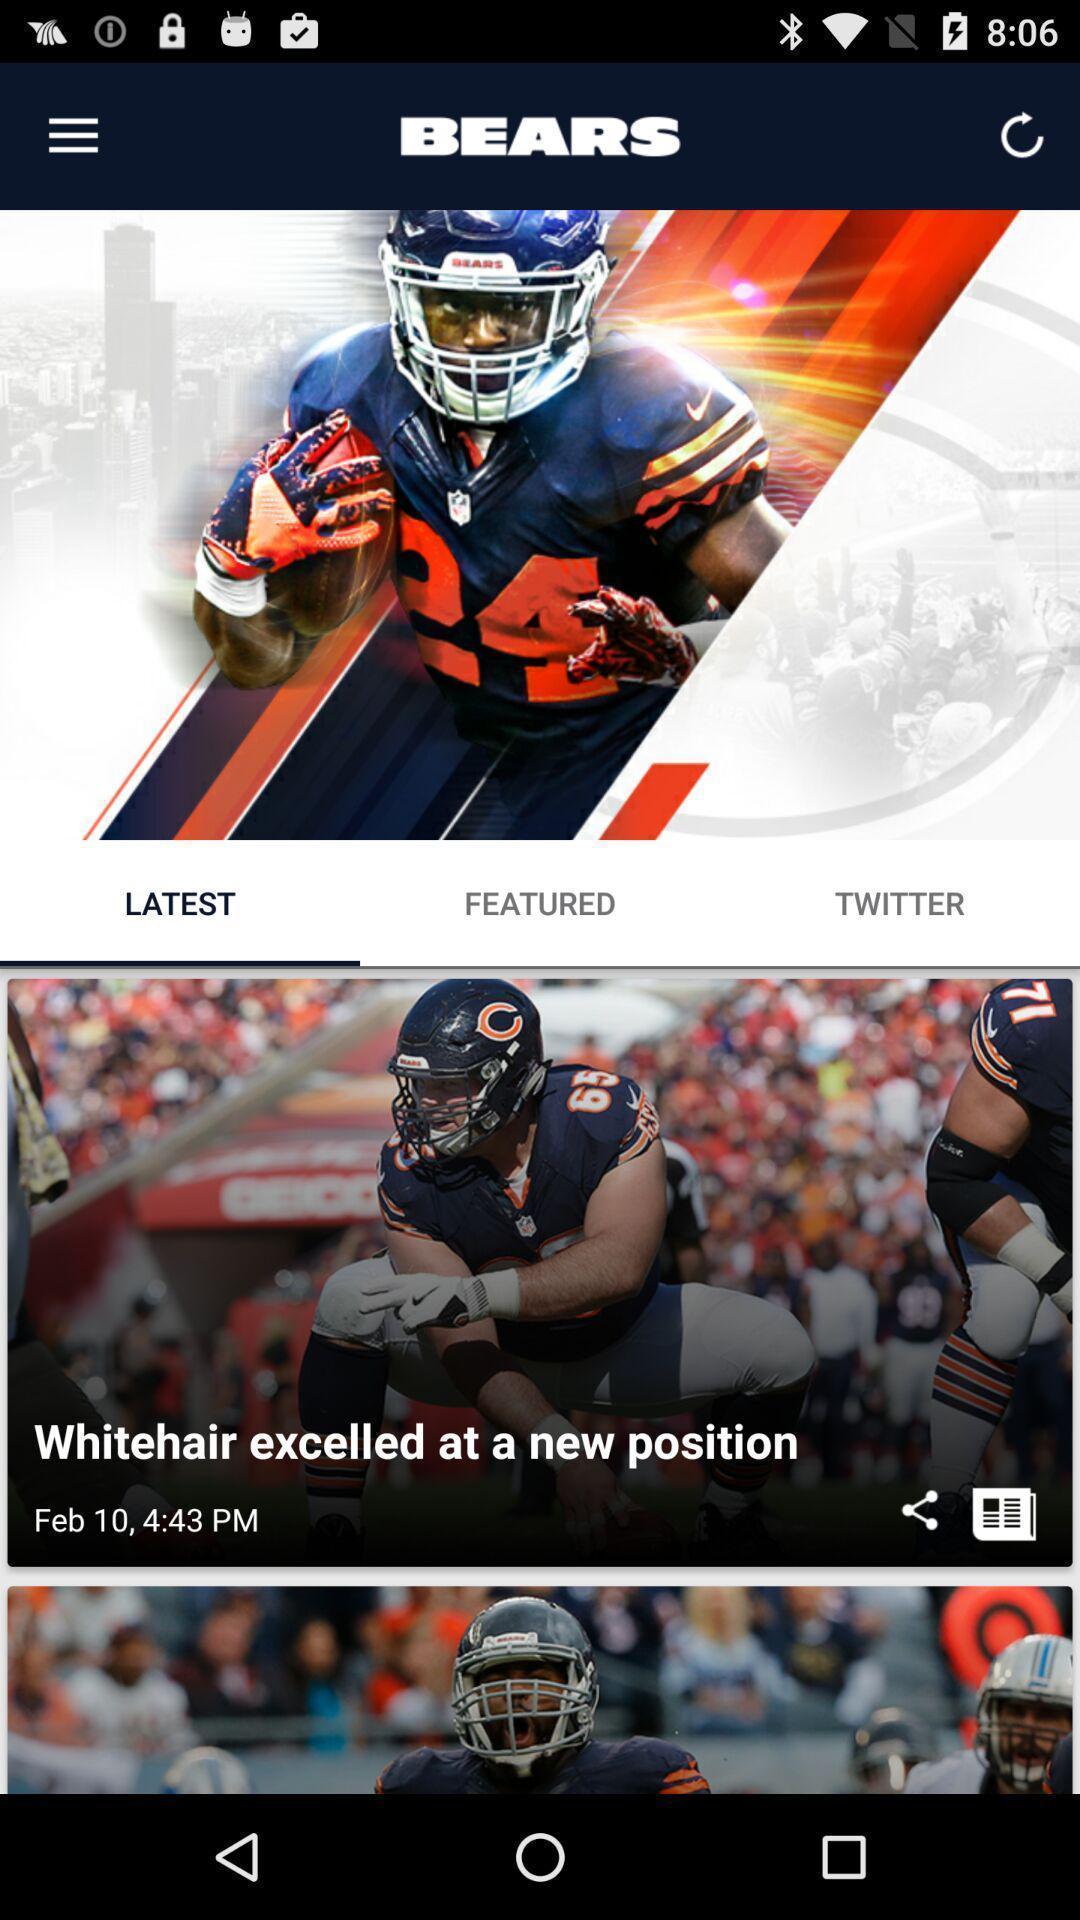Provide a description of this screenshot. Page displaying list of different articles in a gaming app. 